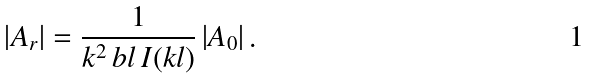Convert formula to latex. <formula><loc_0><loc_0><loc_500><loc_500>\left | A _ { r } \right | = \frac { 1 } { k ^ { 2 } \, b l \, I ( k l ) } \left | A _ { 0 } \right | .</formula> 